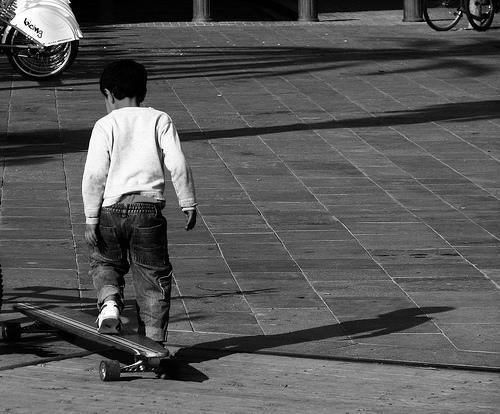How many people?
Give a very brief answer. 1. How many skateboards?
Give a very brief answer. 1. 